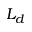<formula> <loc_0><loc_0><loc_500><loc_500>L _ { d }</formula> 